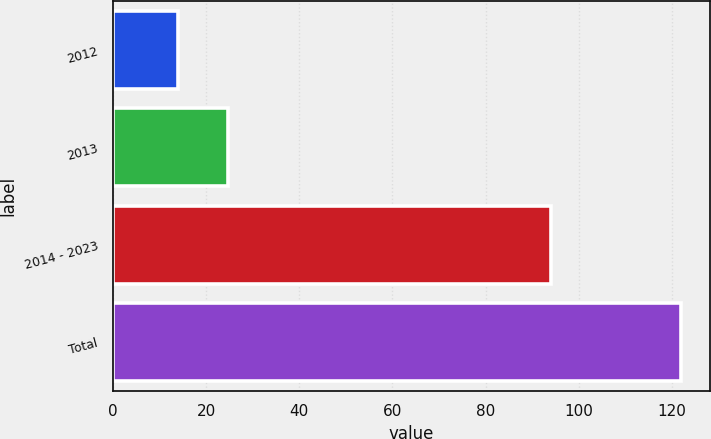Convert chart to OTSL. <chart><loc_0><loc_0><loc_500><loc_500><bar_chart><fcel>2012<fcel>2013<fcel>2014 - 2023<fcel>Total<nl><fcel>14<fcel>24.8<fcel>94<fcel>122<nl></chart> 